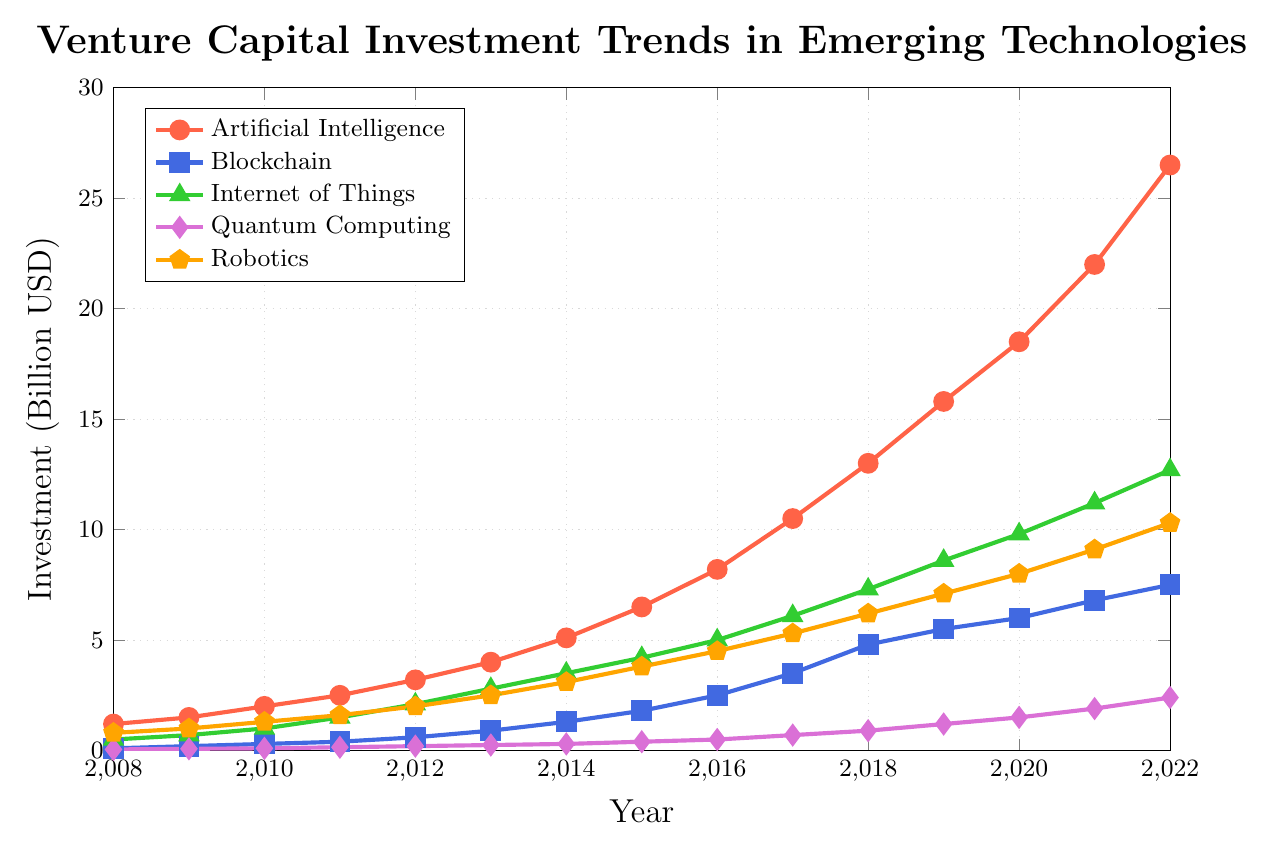What's the overall trend for Venture Capital investment in Artificial Intelligence from 2008 to 2022? The plot shows that the investment in Artificial Intelligence has increased steadily from 1.2 billion USD in 2008 to 26.5 billion USD in 2022.
Answer: Steadily increasing Which emerging technology attracts the highest Venture Capital investment in 2022? By comparing the ending values in 2022 for each technology on the plot, Artificial Intelligence has the highest investment at 26.5 billion USD.
Answer: Artificial Intelligence How does the investment in Robotics in 2015 compare to the investment in Blockchain in 2015? Looking at the values on the plot for 2015, Robotics had an investment of 3.8 billion USD and Blockchain had 1.8 billion USD, thus Robotics had a higher investment.
Answer: Robotics had higher investment Between 2010 and 2015, which technology saw the highest overall growth in Venture Capital investment? Calculating the difference between 2015 and 2010 for each technology: AI increased by 4.5 billion, Blockchain by 1.5 billion, IoT by 3.2 billion, Quantum by 0.3 billion, and Robotics by 2.5 billion. AI had the highest growth at 4.5 billion USD.
Answer: Artificial Intelligence What's the sum of Venture Capital investments in Blockchain and Quantum Computing in 2020? The plot shows Blockchain at 6.0 billion USD and Quantum Computing at 1.5 billion USD in 2020. Their sum is 6.0 + 1.5 = 7.5 billion USD.
Answer: 7.5 billion USD How does the growth rate of investment in IoT from 2008 to 2013 compare with the growth rate of investment in AI in the same period? For IoT: 2.8 - 0.5 = 2.3 billion increase. For AI: 4.0 - 1.2 = 2.8 billion increase. IoT's growth rate is 2.3/0.5 = 4.6, and AI’s growth rate is 2.8/1.2 = 2.33. IoT's growth rate is higher.
Answer: IoT had a higher growth rate What's the average investment in Quantum Computing from 2017 to 2022? Summing up values from 2017 to 2022 for Quantum: 0.7 + 0.9 + 1.2 + 1.5 + 1.9 + 2.4 = 8.6. The average is 8.6/6 = 1.433 billion USD.
Answer: 1.433 billion USD Which technology had the smallest increase in investment from 2019 to 2020? Calculating the differences: AI: 2.7, Blockchain: 0.5, IoT: 1.2, Quantum: 0.3, Robotics: 0.9. Quantum had the smallest increase.
Answer: Quantum Computing How does the volatility (upward and downward changes) of investments in Quantum Computing compare to other technologies? Quantum Computing shows a steadily increasing trend without visible sharp spikes or drops, indicating relatively low volatility compared to other more fluctuating investment trends.
Answer: Lower volatility What is the visual color used to represent Blockchain investments on the chart? The color representing Blockchain in the chart is blue.
Answer: Blue 